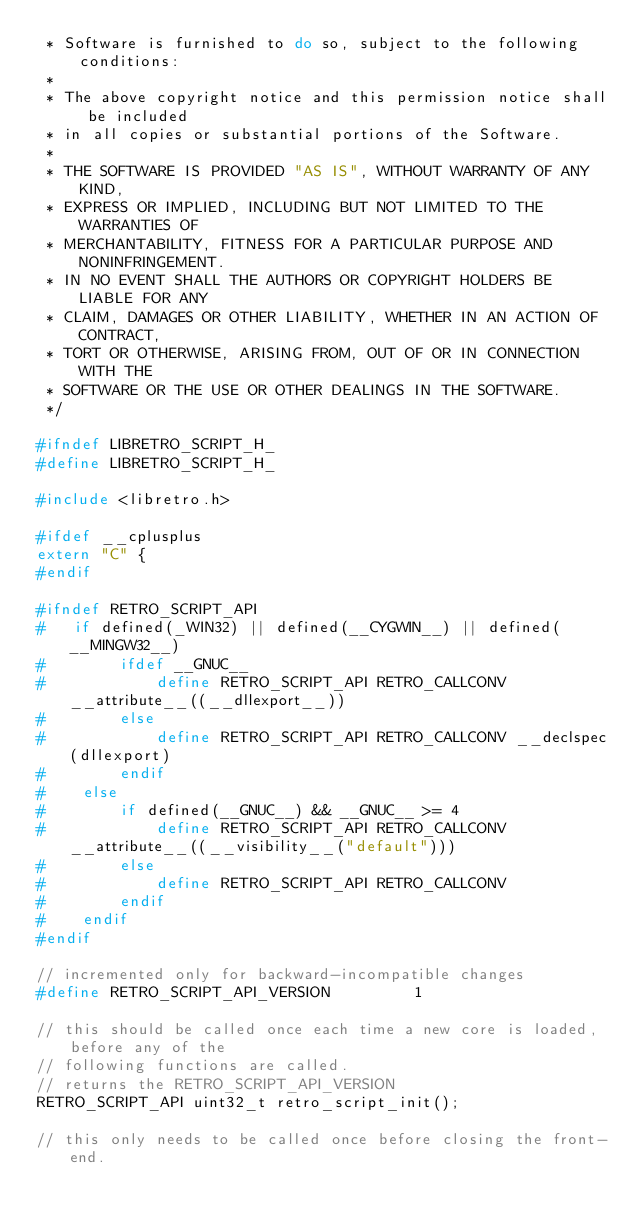Convert code to text. <code><loc_0><loc_0><loc_500><loc_500><_C_> * Software is furnished to do so, subject to the following conditions:
 *
 * The above copyright notice and this permission notice shall be included
 * in all copies or substantial portions of the Software.
 *
 * THE SOFTWARE IS PROVIDED "AS IS", WITHOUT WARRANTY OF ANY KIND,
 * EXPRESS OR IMPLIED, INCLUDING BUT NOT LIMITED TO THE WARRANTIES OF
 * MERCHANTABILITY, FITNESS FOR A PARTICULAR PURPOSE AND NONINFRINGEMENT.
 * IN NO EVENT SHALL THE AUTHORS OR COPYRIGHT HOLDERS BE LIABLE FOR ANY
 * CLAIM, DAMAGES OR OTHER LIABILITY, WHETHER IN AN ACTION OF CONTRACT,
 * TORT OR OTHERWISE, ARISING FROM, OUT OF OR IN CONNECTION WITH THE
 * SOFTWARE OR THE USE OR OTHER DEALINGS IN THE SOFTWARE.
 */

#ifndef LIBRETRO_SCRIPT_H_
#define LIBRETRO_SCRIPT_H_

#include <libretro.h>

#ifdef __cplusplus
extern "C" {
#endif

#ifndef RETRO_SCRIPT_API
#   if defined(_WIN32) || defined(__CYGWIN__) || defined(__MINGW32__) 
#        ifdef __GNUC__
#            define RETRO_SCRIPT_API RETRO_CALLCONV __attribute__((__dllexport__))
#        else
#            define RETRO_SCRIPT_API RETRO_CALLCONV __declspec(dllexport)
#        endif
#    else
#        if defined(__GNUC__) && __GNUC__ >= 4
#            define RETRO_SCRIPT_API RETRO_CALLCONV __attribute__((__visibility__("default")))
#        else
#            define RETRO_SCRIPT_API RETRO_CALLCONV
#        endif
#    endif
#endif

// incremented only for backward-incompatible changes
#define RETRO_SCRIPT_API_VERSION         1

// this should be called once each time a new core is loaded, before any of the 
// following functions are called.
// returns the RETRO_SCRIPT_API_VERSION
RETRO_SCRIPT_API uint32_t retro_script_init();

// this only needs to be called once before closing the front-end.</code> 